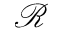Convert formula to latex. <formula><loc_0><loc_0><loc_500><loc_500>\mathcal { R }</formula> 